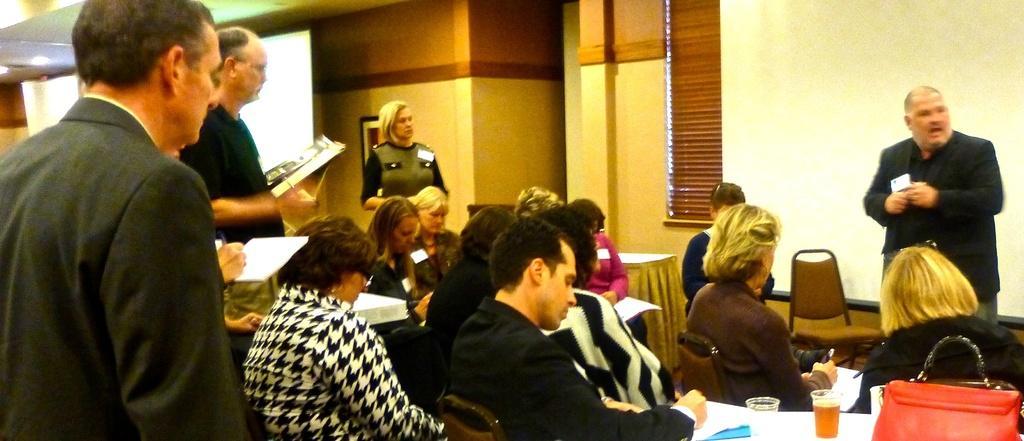Can you describe this image briefly? In this image, group of people are sat on the chairs. We can see few table, few items are placed on it. On the right side, a human is talking and he is standing. The left side and the middle, a woman and 2 peoples are stand. Here we can see wall, photo frame and shade at the middle of the image. 